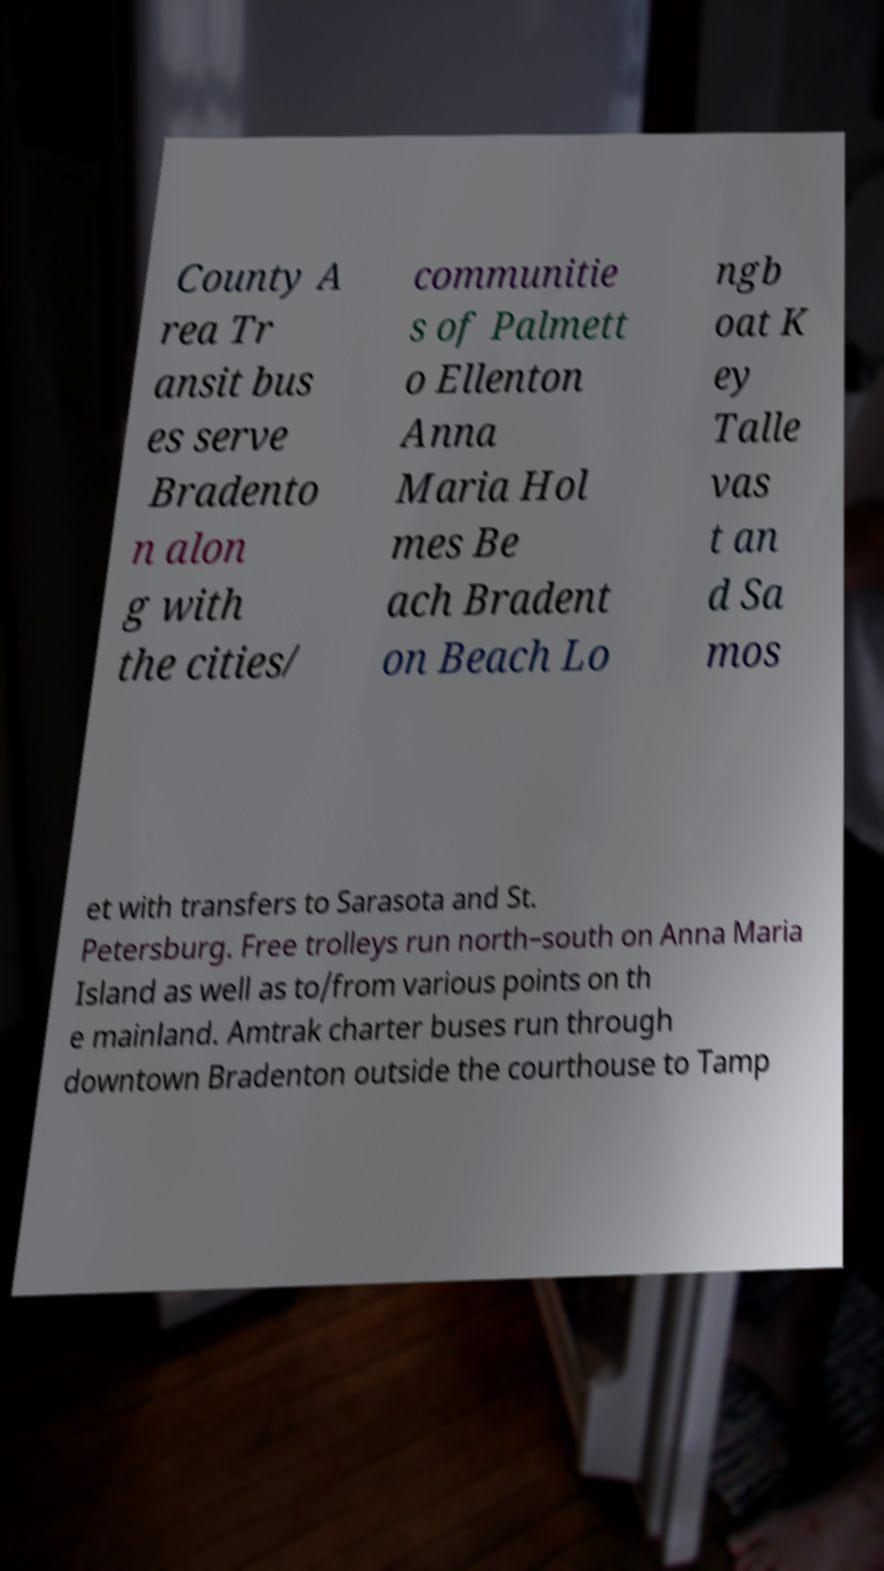Please identify and transcribe the text found in this image. County A rea Tr ansit bus es serve Bradento n alon g with the cities/ communitie s of Palmett o Ellenton Anna Maria Hol mes Be ach Bradent on Beach Lo ngb oat K ey Talle vas t an d Sa mos et with transfers to Sarasota and St. Petersburg. Free trolleys run north–south on Anna Maria Island as well as to/from various points on th e mainland. Amtrak charter buses run through downtown Bradenton outside the courthouse to Tamp 